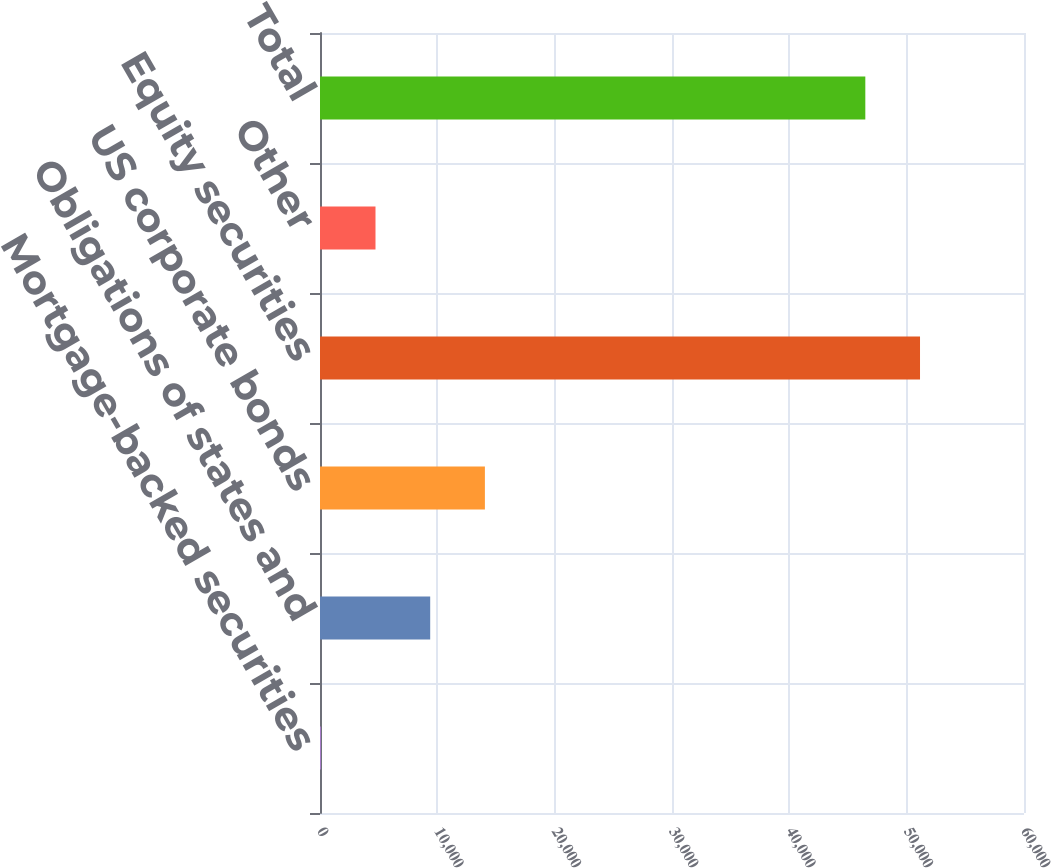<chart> <loc_0><loc_0><loc_500><loc_500><bar_chart><fcel>Mortgage-backed securities<fcel>Obligations of states and<fcel>US corporate bonds<fcel>Equity securities<fcel>Other<fcel>Total<nl><fcel>68<fcel>9392<fcel>14054<fcel>51138<fcel>4730<fcel>46476<nl></chart> 